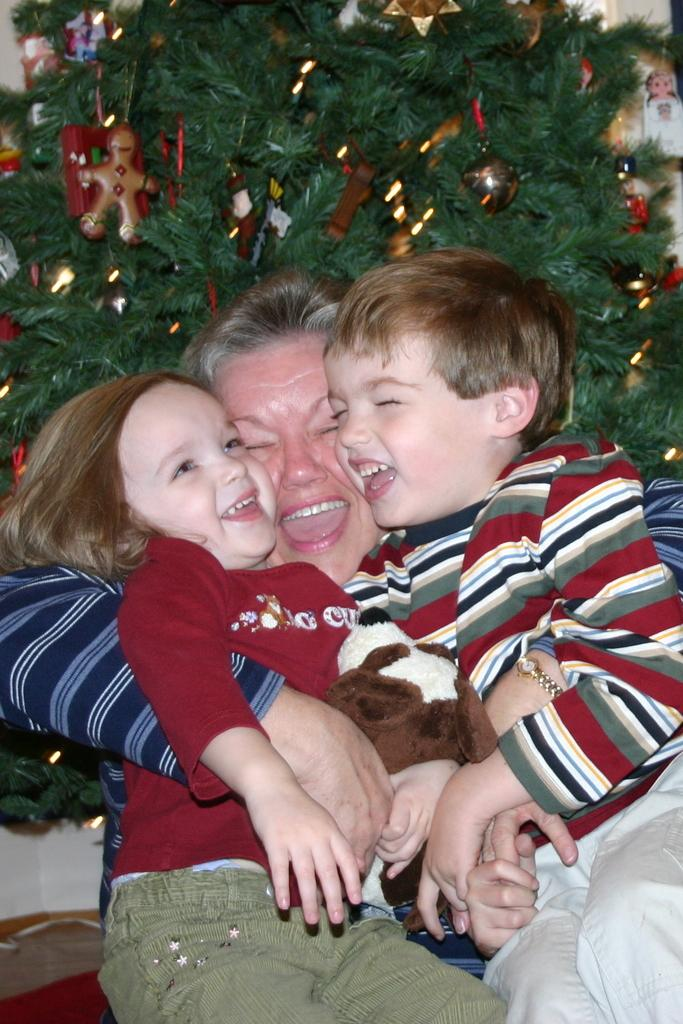What is the lady in the image doing? The lady is sitting and holding kids in the image. What can be seen in the background of the image? There is an Xmas tree in the background of the image. How is the Xmas tree decorated? The Xmas tree has decorations. What relation does the lady have with the rule in the image? There is no rule present in the image, so it is not possible to determine any relation between the lady and a rule. 